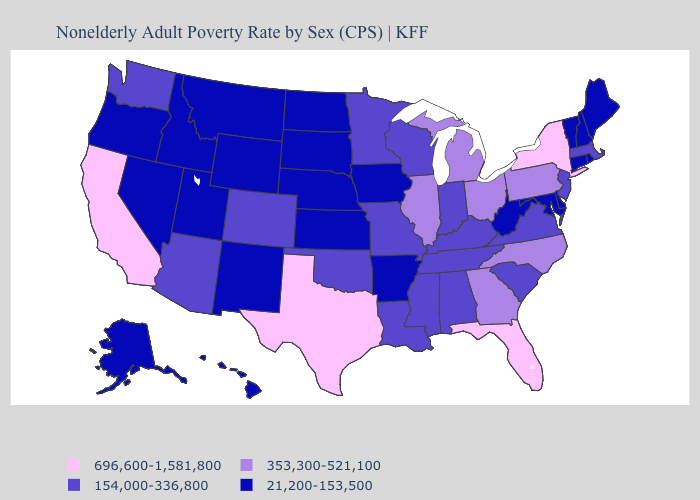Does Nevada have a lower value than California?
Be succinct. Yes. Name the states that have a value in the range 696,600-1,581,800?
Quick response, please. California, Florida, New York, Texas. Name the states that have a value in the range 21,200-153,500?
Be succinct. Alaska, Arkansas, Connecticut, Delaware, Hawaii, Idaho, Iowa, Kansas, Maine, Maryland, Montana, Nebraska, Nevada, New Hampshire, New Mexico, North Dakota, Oregon, Rhode Island, South Dakota, Utah, Vermont, West Virginia, Wyoming. Among the states that border New York , which have the highest value?
Quick response, please. Pennsylvania. Name the states that have a value in the range 696,600-1,581,800?
Quick response, please. California, Florida, New York, Texas. Is the legend a continuous bar?
Give a very brief answer. No. What is the lowest value in states that border Indiana?
Be succinct. 154,000-336,800. Name the states that have a value in the range 154,000-336,800?
Give a very brief answer. Alabama, Arizona, Colorado, Indiana, Kentucky, Louisiana, Massachusetts, Minnesota, Mississippi, Missouri, New Jersey, Oklahoma, South Carolina, Tennessee, Virginia, Washington, Wisconsin. Name the states that have a value in the range 353,300-521,100?
Be succinct. Georgia, Illinois, Michigan, North Carolina, Ohio, Pennsylvania. What is the lowest value in the USA?
Quick response, please. 21,200-153,500. Which states have the lowest value in the West?
Short answer required. Alaska, Hawaii, Idaho, Montana, Nevada, New Mexico, Oregon, Utah, Wyoming. Name the states that have a value in the range 21,200-153,500?
Write a very short answer. Alaska, Arkansas, Connecticut, Delaware, Hawaii, Idaho, Iowa, Kansas, Maine, Maryland, Montana, Nebraska, Nevada, New Hampshire, New Mexico, North Dakota, Oregon, Rhode Island, South Dakota, Utah, Vermont, West Virginia, Wyoming. Which states have the lowest value in the West?
Quick response, please. Alaska, Hawaii, Idaho, Montana, Nevada, New Mexico, Oregon, Utah, Wyoming. What is the lowest value in the USA?
Write a very short answer. 21,200-153,500. Name the states that have a value in the range 154,000-336,800?
Keep it brief. Alabama, Arizona, Colorado, Indiana, Kentucky, Louisiana, Massachusetts, Minnesota, Mississippi, Missouri, New Jersey, Oklahoma, South Carolina, Tennessee, Virginia, Washington, Wisconsin. 